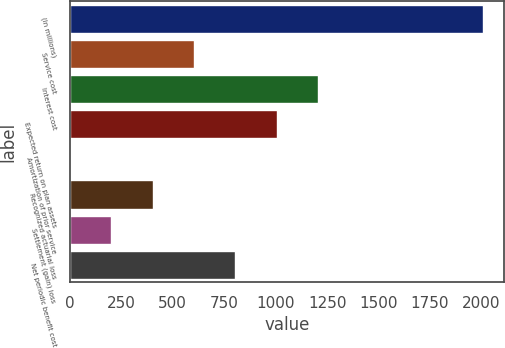Convert chart. <chart><loc_0><loc_0><loc_500><loc_500><bar_chart><fcel>(In millions)<fcel>Service cost<fcel>Interest cost<fcel>Expected return on plan assets<fcel>Amortization of prior service<fcel>Recognized actuarial loss<fcel>Settlement (gain) loss<fcel>Net periodic benefit cost<nl><fcel>2009<fcel>602.98<fcel>1205.56<fcel>1004.7<fcel>0.4<fcel>402.12<fcel>201.26<fcel>803.84<nl></chart> 